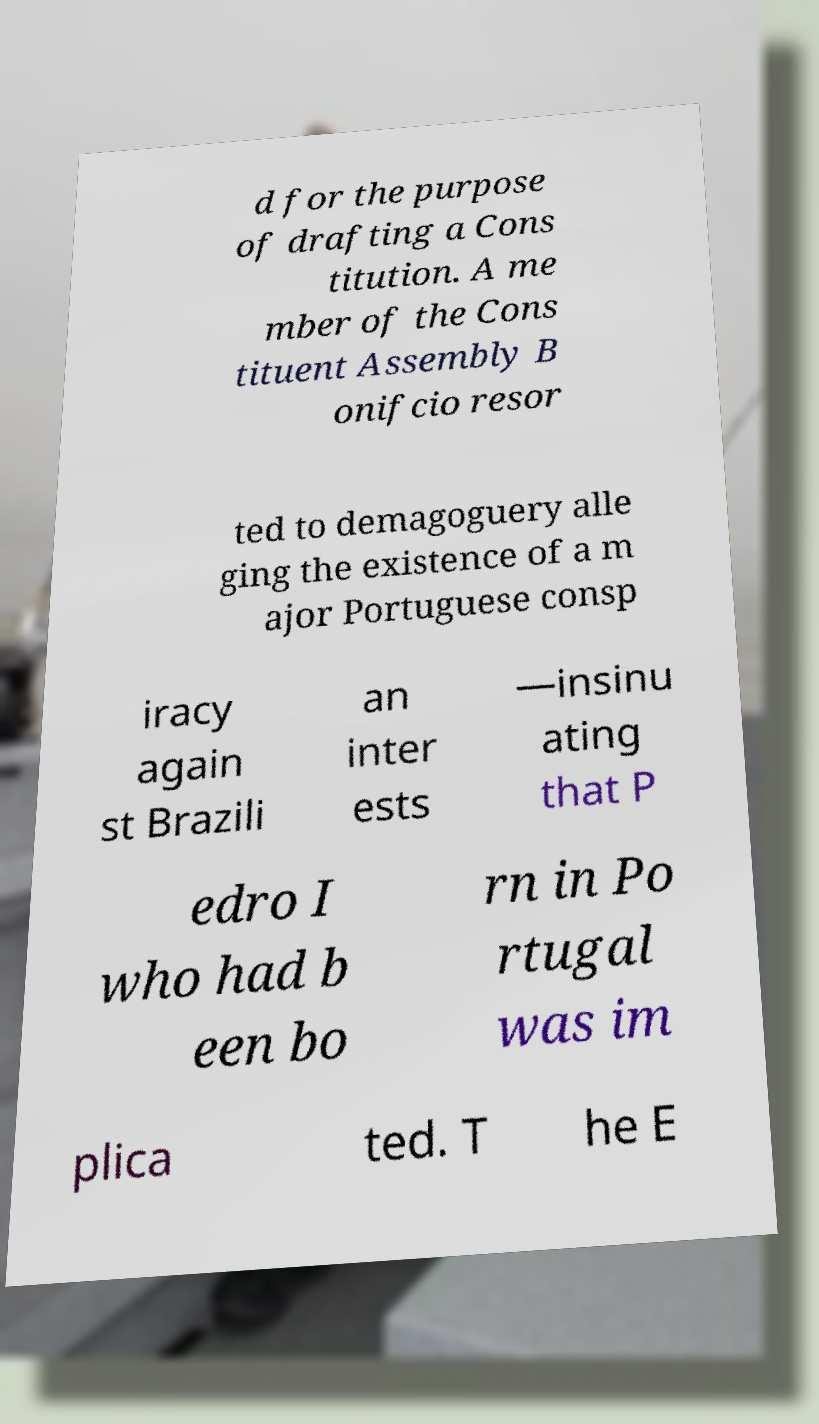For documentation purposes, I need the text within this image transcribed. Could you provide that? d for the purpose of drafting a Cons titution. A me mber of the Cons tituent Assembly B onifcio resor ted to demagoguery alle ging the existence of a m ajor Portuguese consp iracy again st Brazili an inter ests —insinu ating that P edro I who had b een bo rn in Po rtugal was im plica ted. T he E 